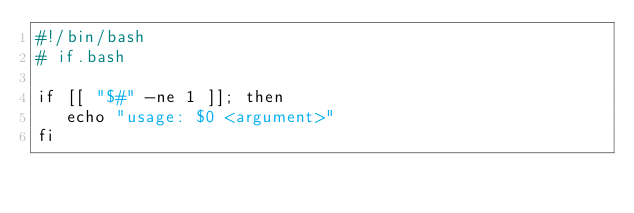<code> <loc_0><loc_0><loc_500><loc_500><_Bash_>#!/bin/bash
# if.bash

if [[ "$#" -ne 1 ]]; then
   echo "usage: $0 <argument>"
fi
</code> 